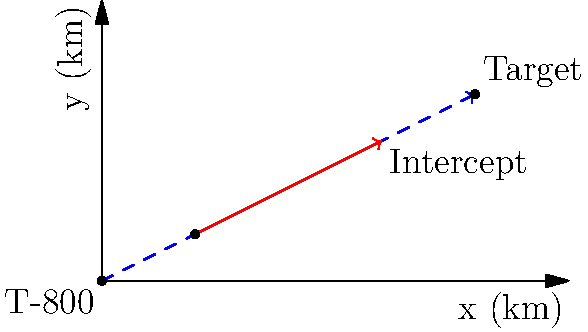A T-800 model Terminator is positioned at the origin (0,0) and needs to intercept a moving target. The target starts at position (2,1) km and moves with a constant velocity of 3 km/h in the positive x-direction and 1.5 km/h in the positive y-direction. If the T-800 can move at a maximum speed of 5 km/h, what is the optimal angle θ (in degrees) at which the T-800 should move to intercept the target in the shortest time possible? To solve this problem, we'll follow these steps:

1) First, let's determine the time it takes for the target to reach the interception point. We can see from the diagram that the interception occurs at (6,3).

   Time for target = $\frac{\text{distance}}{\text{speed}} = \frac{\sqrt{(6-2)^2 + (3-1)^2}}{\sqrt{3^2 + 1.5^2}} = \frac{\sqrt{20}}{\sqrt{11.25}} = \frac{2\sqrt{5}}{\sqrt{11.25}} \approx 1.33$ hours

2) Now, we know that the T-800 must cover a distance of $\sqrt{6^2 + 3^2} = 3\sqrt{5}$ km in the same time.

3) The speed of the T-800 can be calculated:
   
   Speed = $\frac{\text{distance}}{\text{time}} = \frac{3\sqrt{5}}{\frac{2\sqrt{5}}{\sqrt{11.25}}} = \frac{3\sqrt{56.25}}{2} = \frac{3\sqrt{56.25}}{2} \approx 4.47$ km/h

4) This speed is less than the T-800's maximum speed of 5 km/h, so this interception is possible.

5) To find the angle θ, we can use the inverse tangent function:

   $θ = \tan^{-1}(\frac{y}{x}) = \tan^{-1}(\frac{3}{6}) = \tan^{-1}(0.5)$

6) Converting this to degrees:

   $θ = \tan^{-1}(0.5) * \frac{180}{\pi} \approx 26.57°$

Therefore, the optimal angle for the T-800 to move is approximately 26.57 degrees from the positive x-axis.
Answer: 26.57° 